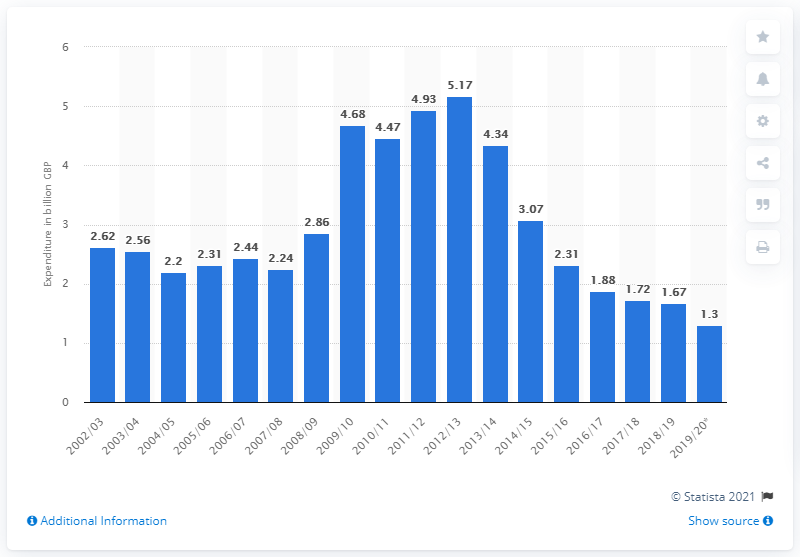Give some essential details in this illustration. The amount of British pounds spent on Jobseekers Allowance in the 2012/13 fiscal year was approximately 5.17 billion pounds. In 2018/19, the UK spent 1.67 billion pounds on Jobseekers Allowance. 